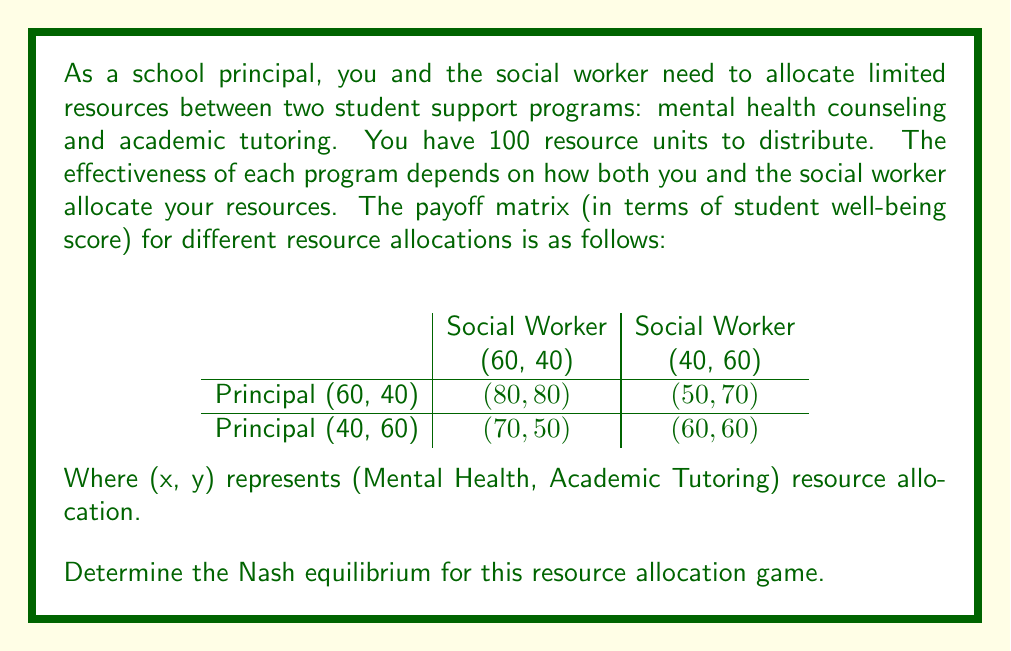Show me your answer to this math problem. To find the Nash equilibrium, we need to identify a strategy profile where neither player has an incentive to unilaterally deviate from their chosen strategy.

Let's analyze each player's best responses:

1. Principal's perspective:
   - If Social Worker chooses (60, 40):
     Principal's payoff for (60, 40): 80
     Principal's payoff for (40, 60): 70
     Best response: (60, 40)
   - If Social Worker chooses (40, 60):
     Principal's payoff for (60, 40): 50
     Principal's payoff for (40, 60): 60
     Best response: (40, 60)

2. Social Worker's perspective:
   - If Principal chooses (60, 40):
     Social Worker's payoff for (60, 40): 80
     Social Worker's payoff for (40, 60): 70
     Best response: (60, 40)
   - If Principal chooses (40, 60):
     Social Worker's payoff for (60, 40): 50
     Social Worker's payoff for (40, 60): 60
     Best response: (40, 60)

A Nash equilibrium occurs when both players are playing their best responses to each other's strategies. From the analysis above, we can see that there are two Nash equilibria:

1. (Principal: (60, 40), Social Worker: (60, 40)) with payoffs (80, 80)
2. (Principal: (40, 60), Social Worker: (40, 60)) with payoffs (60, 60)

In both cases, neither player has an incentive to unilaterally change their strategy, as doing so would result in a lower payoff.
Answer: The Nash equilibria for this resource allocation game are:
1. (Principal: (60, 40), Social Worker: (60, 40)) with payoffs (80, 80)
2. (Principal: (40, 60), Social Worker: (40, 60)) with payoffs (60, 60) 